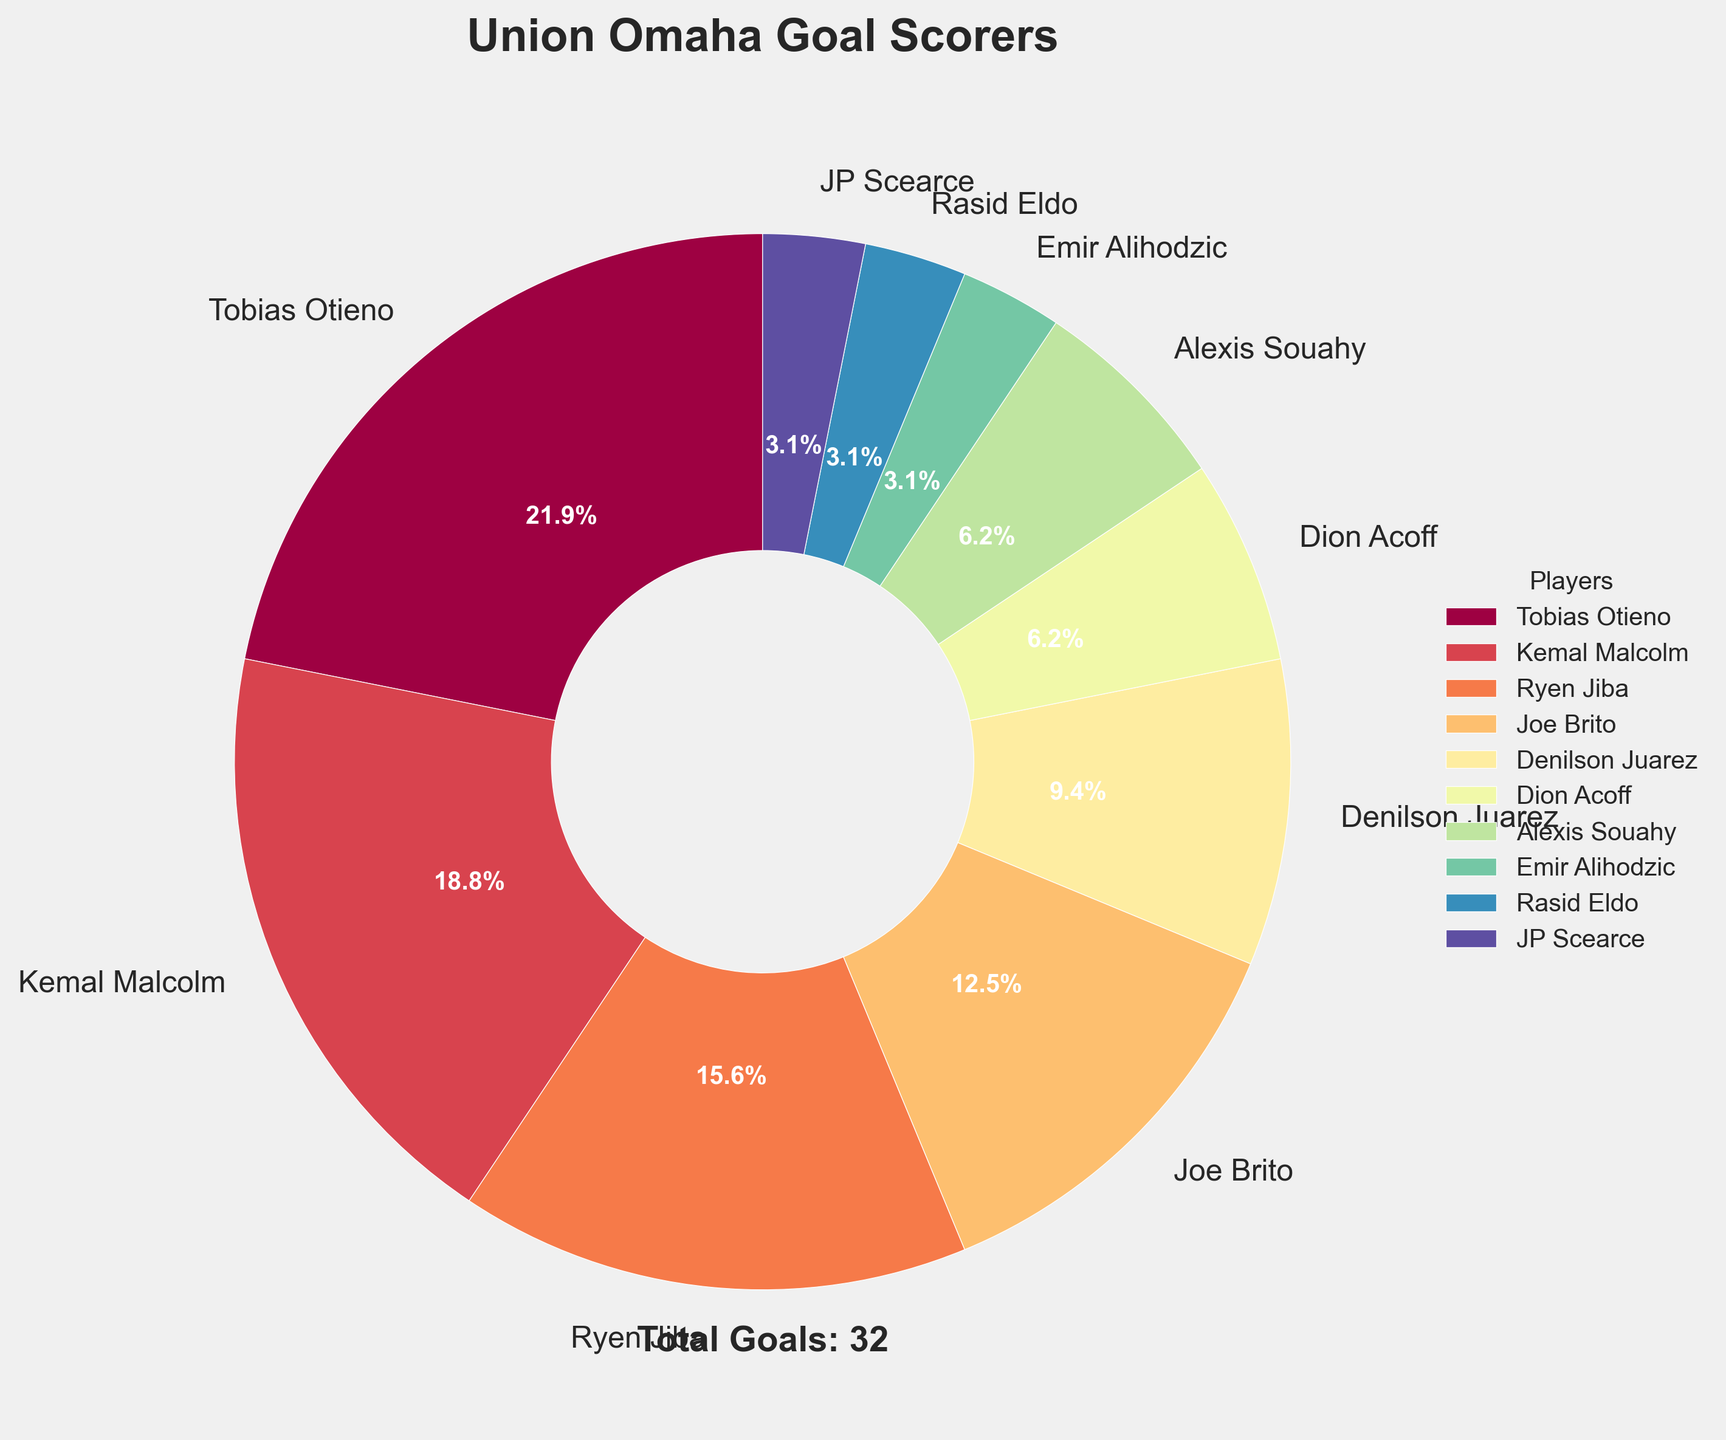who scored the most goals for Union Omaha this season? By looking at the pie chart and the sizes of the slices, the largest slice is labeled "Tobias Otieno," indicating he scored the most goals.
Answer: Tobias Otieno how many players scored more than 5 goals? By examining the chart, the slices labeled "Tobias Otieno" and "Kemal Malcolm" both indicate goal numbers higher than 5.
Answer: 2 what is the combined percentage of goals scored by Denilson Juarez and Joe Brito? From the pie chart, Denilson Juarez scored 3 goals, and Joe Brito scored 4 goals. Their combined goal count is 3 + 4 = 7 goals. The total number of goals in the chart is 32, so the combined percentage is (7/32) * 100.
Answer: 21.9% which player scored the least number of goals? The smallest slices on the pie chart are labeled "Emir Alihodzic," "Rasid Eldo," and "JP Scearce," each corresponding to 1 goal.
Answer: Emir Alihodzic, Rasid Eldo, JP Scearce what is the percentage difference between Tobias Otieno's and Ryen Jiba's goals? Tobias Otieno scored 7 goals, while Ryen Jiba scored 5. The percentage of Tobias Otieno's goals is (7/32) * 100 = 21.9% and for Ryen Jiba is (5/32) * 100 = 15.6%. The difference is 21.9% - 15.6%.
Answer: 6.3% which player has a goal count closest to the average number of goals scored? First, calculate the average number of goals: The total number of goals is 32, and there are 10 players, so the average is 32/10 = 3.2. The player closest to this count is Denilson Juarez with 3 goals.
Answer: Denilson Juarez who are the players with an equal number of goals? By examining the pie chart, "Dion Acoff" and "Alexis Souahy" both have 2 goals each. Similarly, "Emir Alihodzic," "Rasid Eldo," and "JP Scearce" each have 1 goal.
Answer: Dion Acoff, Alexis Souahy, Emir Alihodzic, Rasid Eldo, JP Scearce 